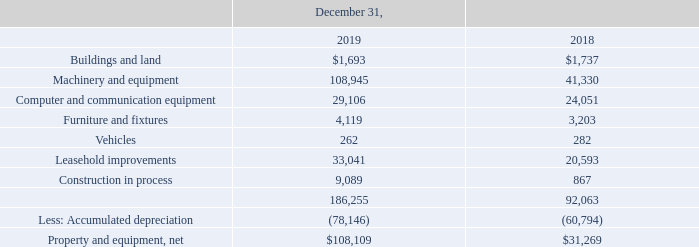ADVANCED ENERGY INDUSTRIES, INC. NOTES TO CONSOLIDATED FINANCIAL STATEMENTS – (continued) (in thousands, except per share amounts)
NOTE 11. PROPERTY AND EQUIPMENT, NET
Property and equipment, net is comprised of the following:
What was the amount for buildings and land in 2019?
Answer scale should be: thousand. $1,693. What was the amount for Machinery and equipment in 2018?
Answer scale should be: thousand. 41,330. What was the amount of Computer and communication equipment in 2019?
Answer scale should be: thousand. 29,106. What was the sum of the three highest property and equipment in 2019?
Answer scale should be: thousand. 108,945+29,106+33,041
Answer: 171092. What are the three highest property and equipment components in 2018? Find the 3 largest values for Rows 3 to 9, COL4 and the corresponding component in COL2
Answer: machinery and equipment, computer and communication equipment, leasehold improvements. What was the percentage change in the net property and equipment between 2018 and 2019?
Answer scale should be: percent. ($108,109-$31,269)/$31,269
Answer: 245.74. 